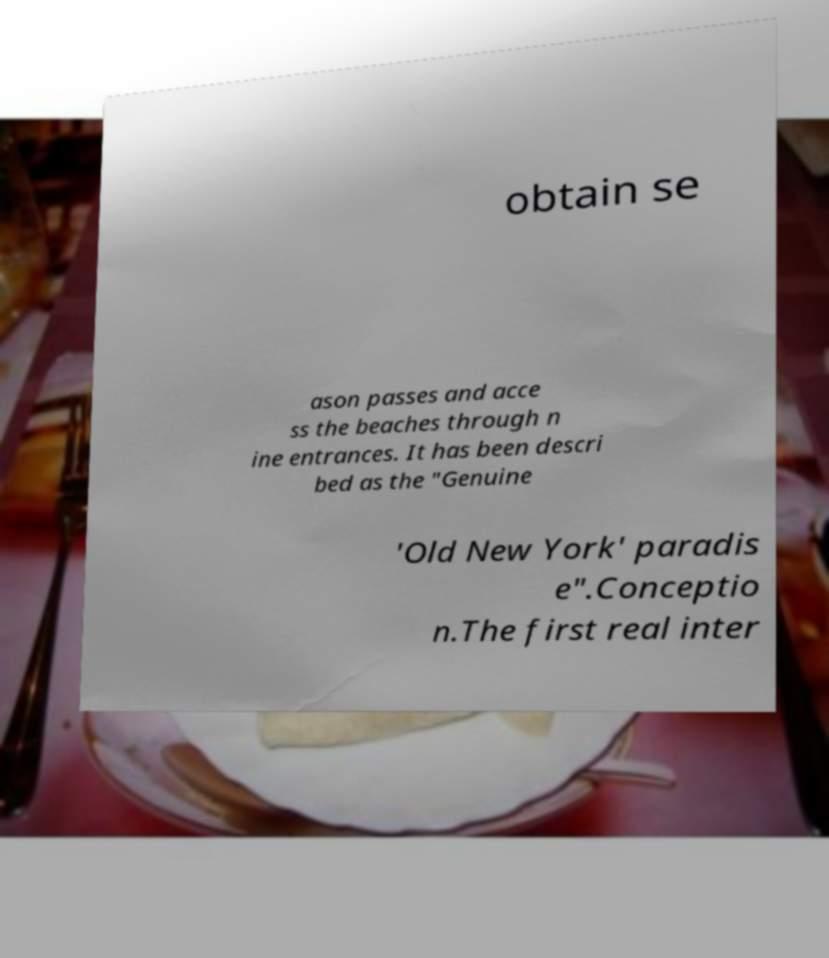Could you extract and type out the text from this image? obtain se ason passes and acce ss the beaches through n ine entrances. It has been descri bed as the "Genuine 'Old New York' paradis e".Conceptio n.The first real inter 